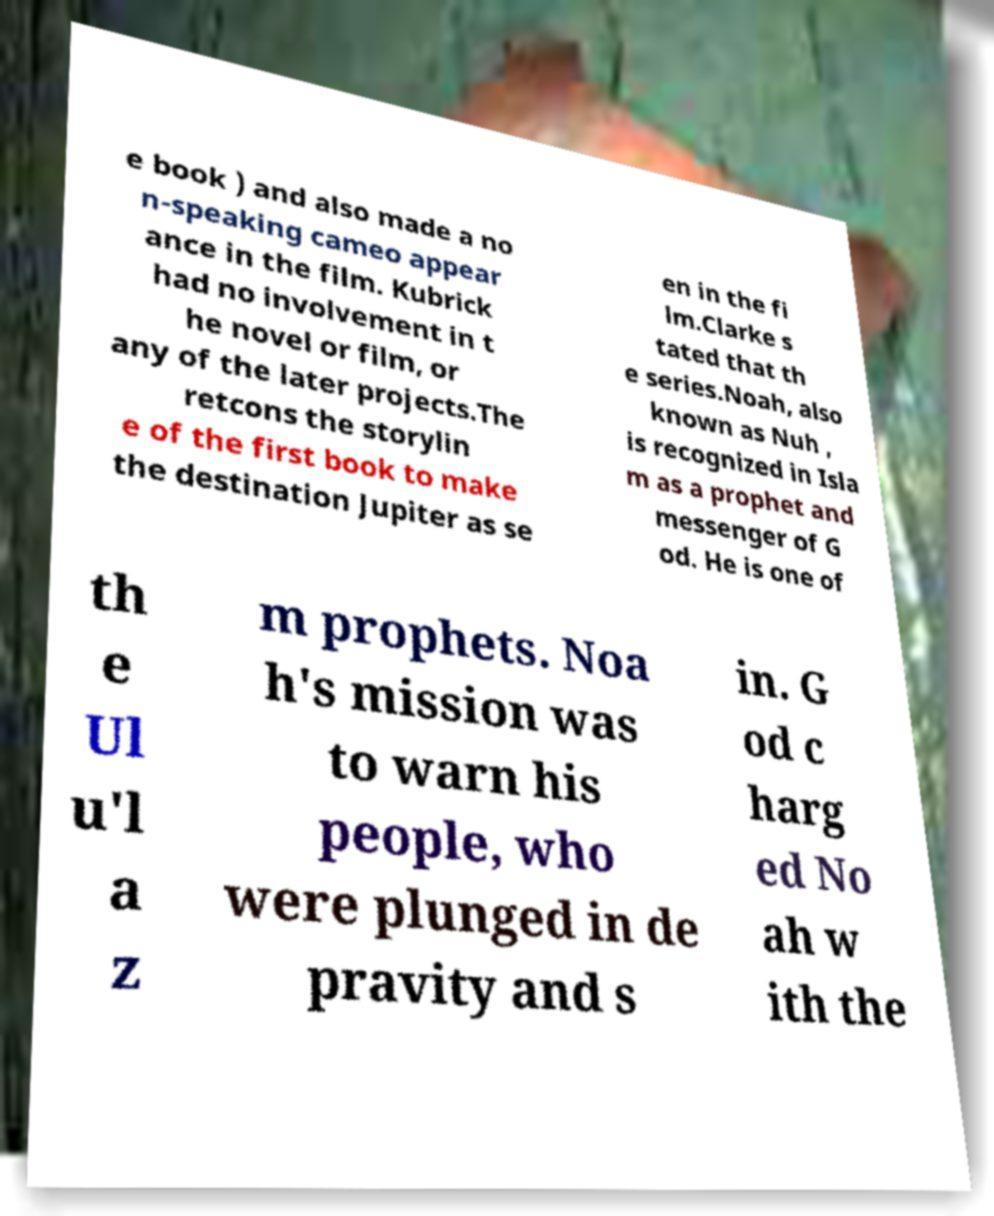Please read and relay the text visible in this image. What does it say? e book ) and also made a no n-speaking cameo appear ance in the film. Kubrick had no involvement in t he novel or film, or any of the later projects.The retcons the storylin e of the first book to make the destination Jupiter as se en in the fi lm.Clarke s tated that th e series.Noah, also known as Nuh , is recognized in Isla m as a prophet and messenger of G od. He is one of th e Ul u'l a z m prophets. Noa h's mission was to warn his people, who were plunged in de pravity and s in. G od c harg ed No ah w ith the 